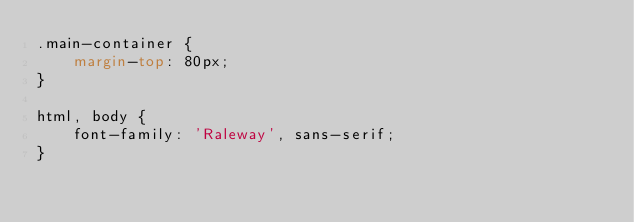<code> <loc_0><loc_0><loc_500><loc_500><_CSS_>.main-container {
    margin-top: 80px;
}

html, body {
    font-family: 'Raleway', sans-serif;
}</code> 